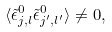<formula> <loc_0><loc_0><loc_500><loc_500>\langle \tilde { \epsilon } ^ { 0 } _ { j , l } \tilde { \epsilon } ^ { 0 } _ { j ^ { \prime } , l ^ { \prime } } \rangle \neq 0 ,</formula> 